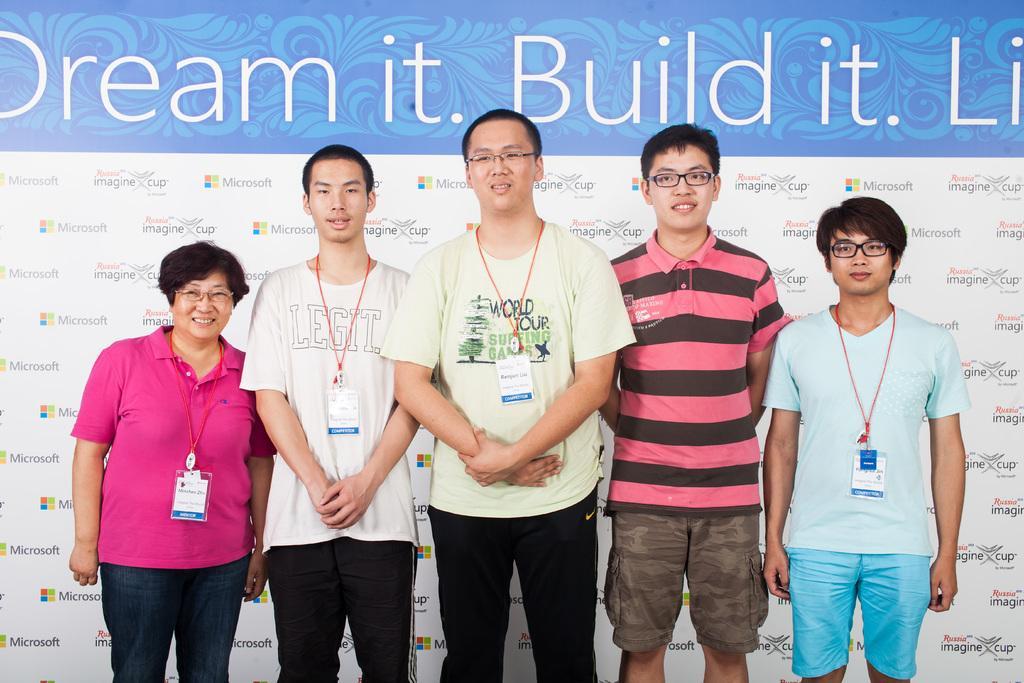Could you give a brief overview of what you see in this image? In the center of the image there are people standing wearing Id cards. In the background of the image there is a banner with some text on it. 